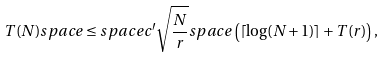<formula> <loc_0><loc_0><loc_500><loc_500>T ( N ) s p a c e \leq s p a c e c ^ { \prime } \sqrt { \frac { N } { r } } s p a c e \left ( \lceil \log ( N + 1 ) \rceil + T ( r ) \right ) ,</formula> 